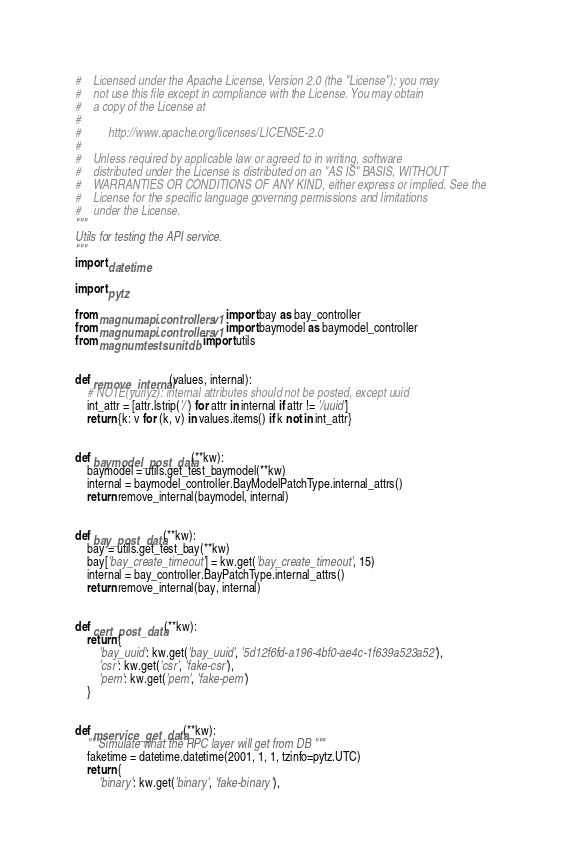Convert code to text. <code><loc_0><loc_0><loc_500><loc_500><_Python_>#    Licensed under the Apache License, Version 2.0 (the "License"); you may
#    not use this file except in compliance with the License. You may obtain
#    a copy of the License at
#
#         http://www.apache.org/licenses/LICENSE-2.0
#
#    Unless required by applicable law or agreed to in writing, software
#    distributed under the License is distributed on an "AS IS" BASIS, WITHOUT
#    WARRANTIES OR CONDITIONS OF ANY KIND, either express or implied. See the
#    License for the specific language governing permissions and limitations
#    under the License.
"""
Utils for testing the API service.
"""
import datetime

import pytz

from magnum.api.controllers.v1 import bay as bay_controller
from magnum.api.controllers.v1 import baymodel as baymodel_controller
from magnum.tests.unit.db import utils


def remove_internal(values, internal):
    # NOTE(yuriyz): internal attributes should not be posted, except uuid
    int_attr = [attr.lstrip('/') for attr in internal if attr != '/uuid']
    return {k: v for (k, v) in values.items() if k not in int_attr}


def baymodel_post_data(**kw):
    baymodel = utils.get_test_baymodel(**kw)
    internal = baymodel_controller.BayModelPatchType.internal_attrs()
    return remove_internal(baymodel, internal)


def bay_post_data(**kw):
    bay = utils.get_test_bay(**kw)
    bay['bay_create_timeout'] = kw.get('bay_create_timeout', 15)
    internal = bay_controller.BayPatchType.internal_attrs()
    return remove_internal(bay, internal)


def cert_post_data(**kw):
    return {
        'bay_uuid': kw.get('bay_uuid', '5d12f6fd-a196-4bf0-ae4c-1f639a523a52'),
        'csr': kw.get('csr', 'fake-csr'),
        'pem': kw.get('pem', 'fake-pem')
    }


def mservice_get_data(**kw):
    """Simulate what the RPC layer will get from DB """
    faketime = datetime.datetime(2001, 1, 1, tzinfo=pytz.UTC)
    return {
        'binary': kw.get('binary', 'fake-binary'),</code> 